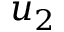<formula> <loc_0><loc_0><loc_500><loc_500>u _ { 2 }</formula> 